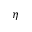<formula> <loc_0><loc_0><loc_500><loc_500>\eta</formula> 